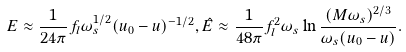<formula> <loc_0><loc_0><loc_500><loc_500>E \approx \frac { 1 } { 2 4 \pi } f _ { l } \omega _ { s } ^ { 1 / 2 } ( u _ { 0 } - u ) ^ { - 1 / 2 } , \hat { E } \approx \frac { 1 } { 4 8 \pi } f _ { l } ^ { 2 } \omega _ { s } \ln \frac { ( M \omega _ { s } ) ^ { 2 / 3 } } { \omega _ { s } ( u _ { 0 } - u ) } .</formula> 